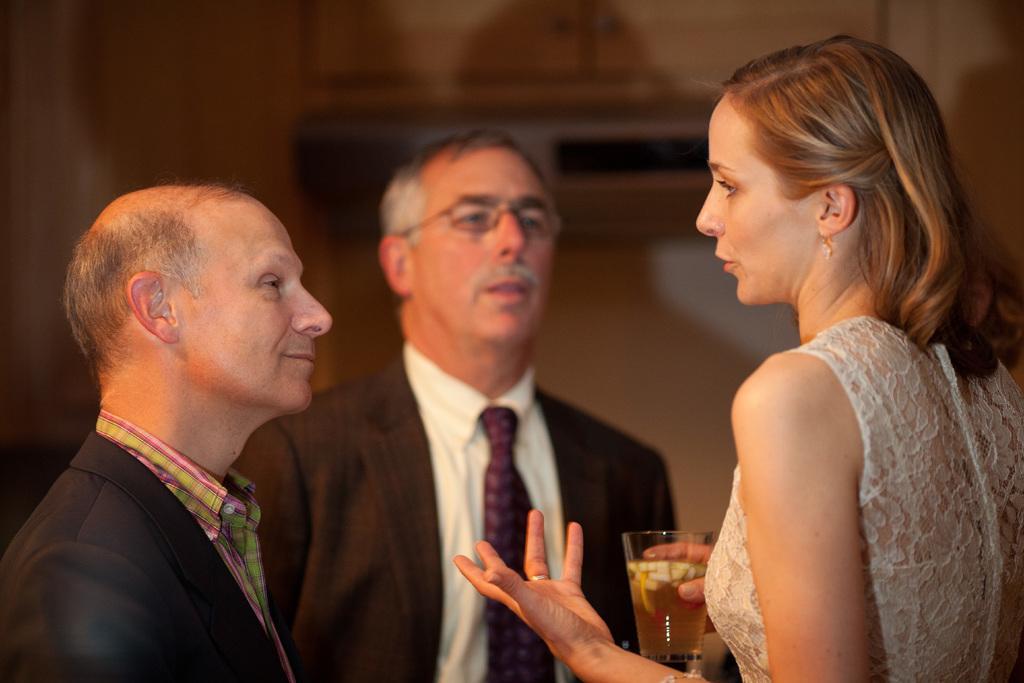In one or two sentences, can you explain what this image depicts? In this image, we can see two men standing, on the right side there is a woman standing and holding a glass, in the background we can see a wall. 